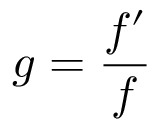Convert formula to latex. <formula><loc_0><loc_0><loc_500><loc_500>g = { \frac { f ^ { \prime } } { f } }</formula> 